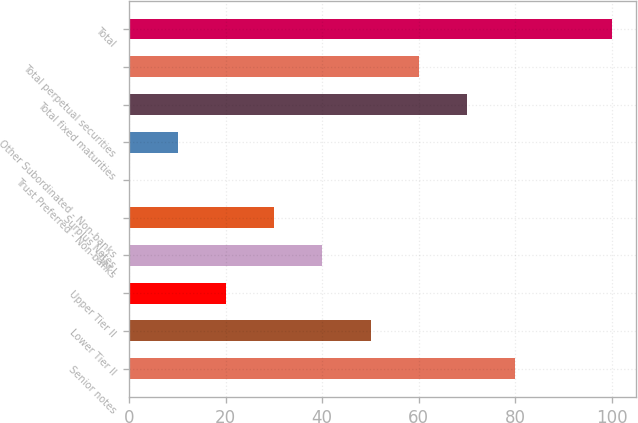Convert chart. <chart><loc_0><loc_0><loc_500><loc_500><bar_chart><fcel>Senior notes<fcel>Lower Tier II<fcel>Upper Tier II<fcel>Tier I<fcel>Surplus Notes<fcel>Trust Preferred - Non-banks<fcel>Other Subordinated - Non-banks<fcel>Total fixed maturities<fcel>Total perpetual securities<fcel>Total<nl><fcel>80.02<fcel>50.05<fcel>20.08<fcel>40.06<fcel>30.07<fcel>0.1<fcel>10.09<fcel>70.03<fcel>60.04<fcel>100<nl></chart> 